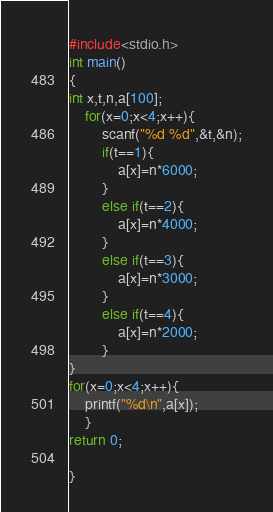Convert code to text. <code><loc_0><loc_0><loc_500><loc_500><_C_>#include<stdio.h>
int main()
{
int x,t,n,a[100];
	for(x=0;x<4;x++){
		scanf("%d %d",&t,&n);
		if(t==1){
			a[x]=n*6000;
		}
		else if(t==2){
			a[x]=n*4000;
		}
		else if(t==3){
   			a[x]=n*3000;
		}
		else if(t==4){
			a[x]=n*2000;
		}
}
for(x=0;x<4;x++){
	printf("%d\n",a[x]);
	}
return 0;

}</code> 